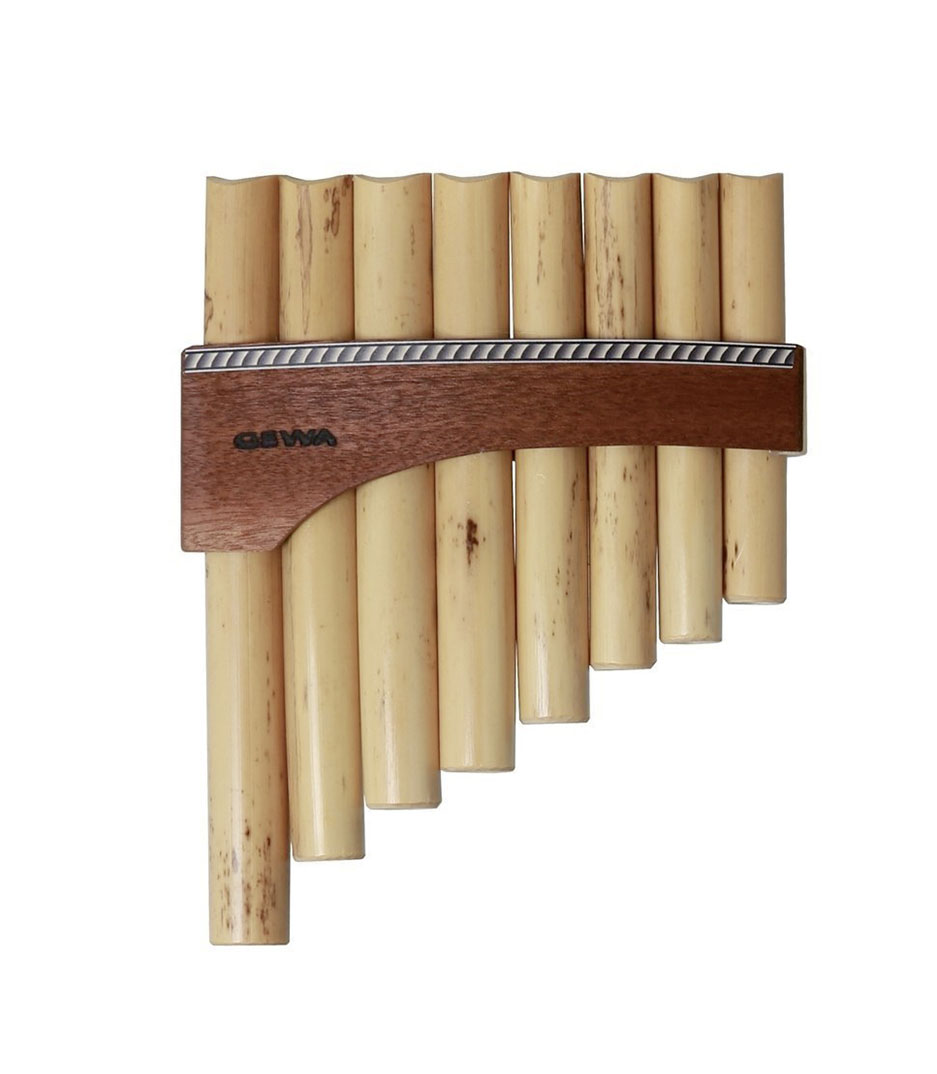Imagine if each pipe of the pan flute had magical powers. What could each one do? Imagine a magical pan flute where each pipe held a unique power. The longest pipe could command the winds, bringing gentle breezes or mighty gusts at the player's whim. The next pipe could summon rain, nourishing crops and filling rivers. Another pipe might cause plants to grow and flowers to bloom instantly. One pipe could communicate with animals, allowing the musician to understand and befriend any creature. Another pipe might create light, shining like a beacon in the darkness. Yet another might heal wounds, knitting flesh and bone back together. Together, these pipes would make the pan flute a powerful tool for balancing and nurturing the world, harmonizing the forces of nature with the musician's melodies. 